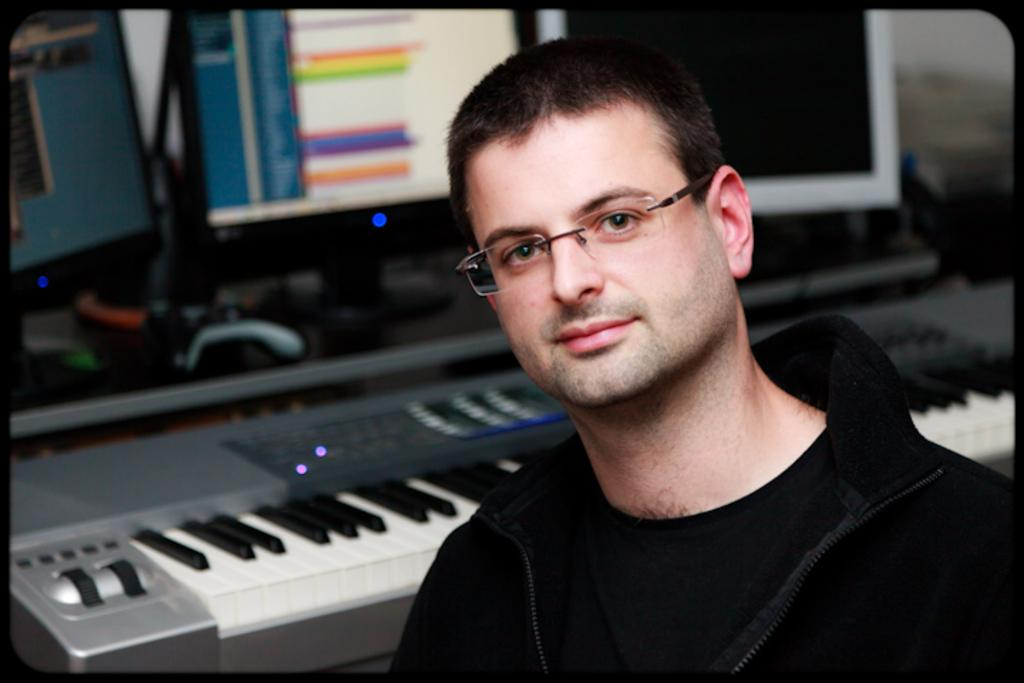Who is present in the image? There is a man in the image. What is the man wearing? The man is wearing spectacles. What object is the man standing in front of? The man is in front of a piano. What can be seen in the background of the image? There are two monitors in the background of the image. Can you see any forks or ducks in the image? No, there are no forks or ducks present in the image. 